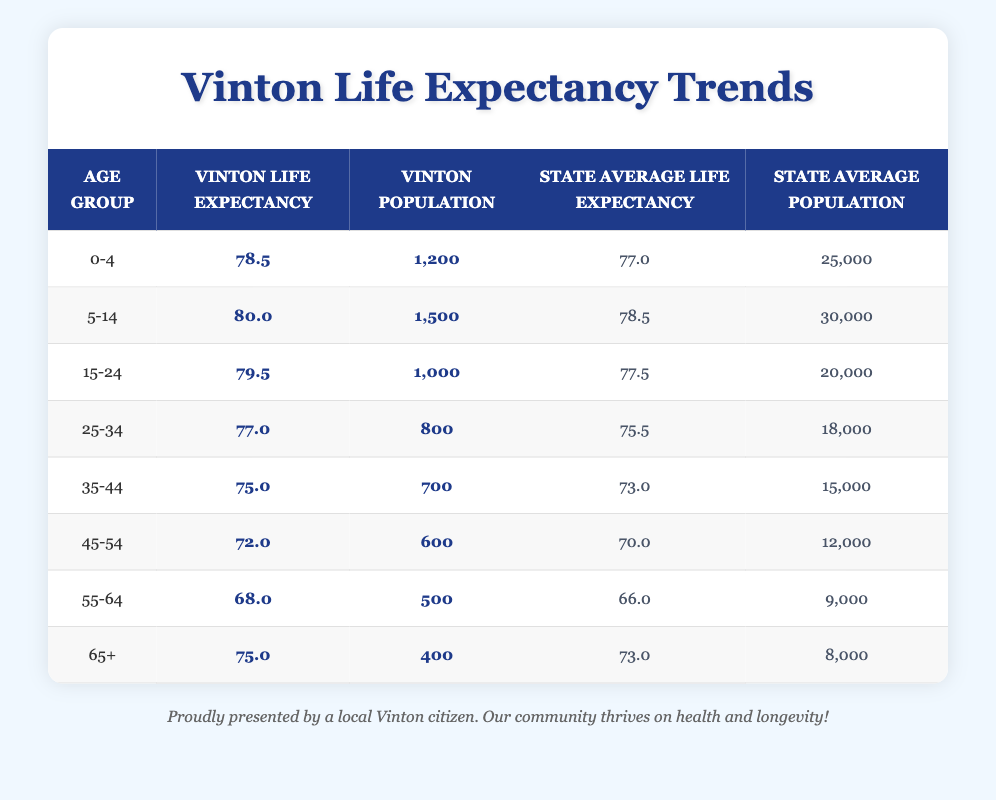What is the life expectancy for the age group 5-14 in Vinton? Looking at the table, under the age group 5-14, Vinton's life expectancy is listed as 80.0.
Answer: 80.0 What is the state average life expectancy for the age group 25-34? The state average life expectancy for the age group 25-34 is given as 75.5 in the table.
Answer: 75.5 Is the life expectancy for the age group 45-54 in Vinton higher than the state average? In Vinton, the life expectancy for the age group 45-54 is 72.0, while the state average is 70.0. Since 72.0 is greater than 70.0, the answer is yes.
Answer: Yes Which age group has the highest life expectancy in Vinton? By comparing the life expectancy values in the Vinton section, the age group 5-14 has the highest life expectancy of 80.0.
Answer: 5-14 What is the difference in life expectancy between the 65+ age group in Vinton and the state average? In Vinton, the life expectancy for the 65+ age group is 75.0, while the state average is 73.0. To find the difference, subtract 73.0 from 75.0, which equals 2.0.
Answer: 2.0 What is the average life expectancy in Vinton for all age groups? To find the average, add up the life expectancies for all age groups in Vinton: 78.5 + 80.0 + 79.5 + 77.0 + 75.0 + 72.0 + 68.0 + 75.0 = 605.0. Next, divide by the number of age groups, which is 8. The average is 605.0 / 8 = 75.625.
Answer: 75.625 Is it true that the life expectancy for the 55-64 age group is lower in Vinton compared to the state average? Vinton has a life expectancy of 68.0 for the 55-64 age group, while the state average is 66.0. Since 68.0 is greater than 66.0, the statement is false.
Answer: No For which age group does Vinton have the closest life expectancy compared to the state average? The age group 25-34 in Vinton has a life expectancy of 77.0, while the state average is 75.5. The difference is 1.5, which is lower than any other age group's difference, indicating they are closest together in life expectancy.
Answer: 25-34 